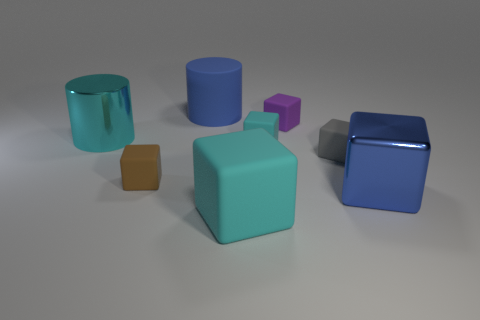Do the blue object that is right of the tiny purple matte cube and the purple matte thing have the same shape?
Your response must be concise. Yes. Are there fewer large cyan objects than rubber cylinders?
Make the answer very short. No. Is there anything else of the same color as the metallic cube?
Offer a terse response. Yes. The shiny object on the left side of the small brown thing has what shape?
Your answer should be compact. Cylinder. Is the color of the large matte block the same as the large metal object behind the large blue shiny block?
Provide a short and direct response. Yes. Is the number of rubber cubes behind the large matte block the same as the number of small cyan matte cubes in front of the small brown thing?
Your answer should be very brief. No. What number of other things are there of the same size as the blue shiny thing?
Your response must be concise. 3. What is the size of the gray cube?
Offer a very short reply. Small. Does the tiny purple block have the same material as the cyan block that is in front of the brown cube?
Your answer should be compact. Yes. Is there a big cyan object that has the same shape as the small cyan rubber thing?
Your answer should be very brief. Yes. 